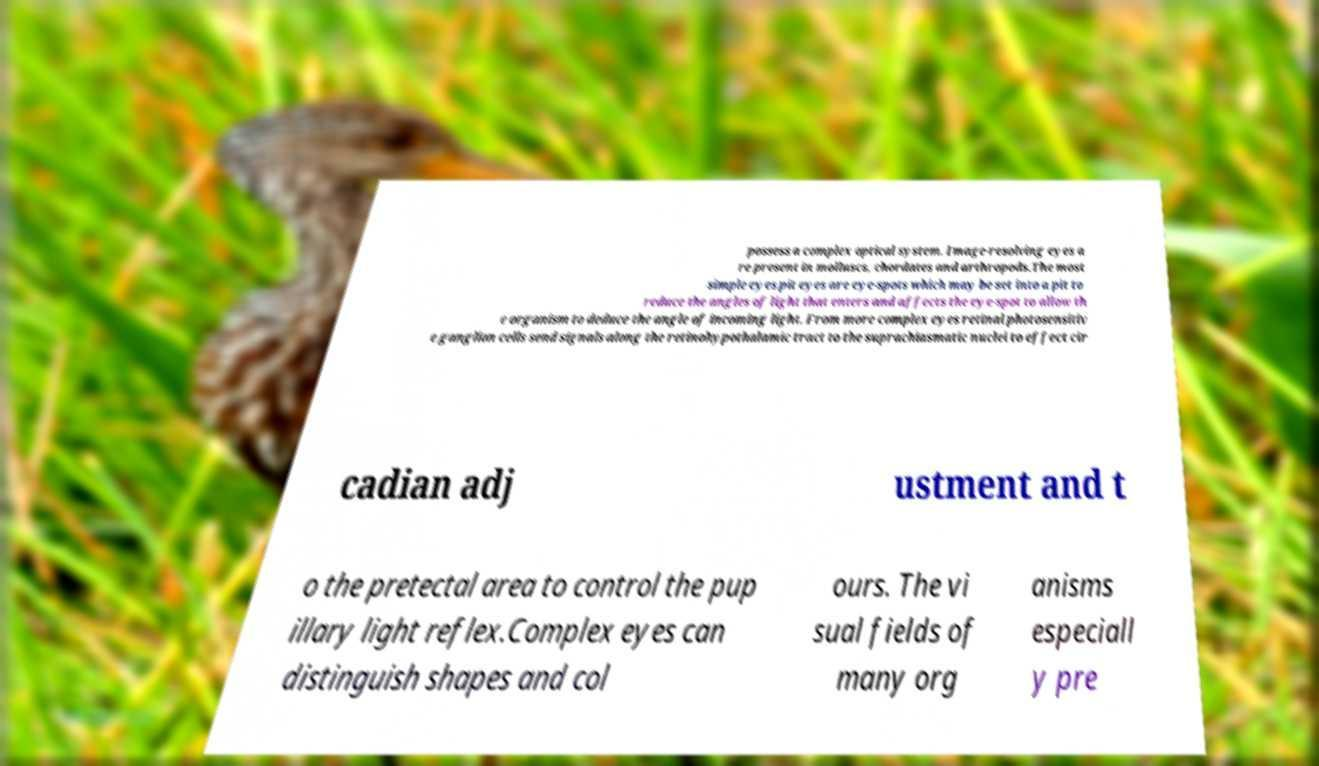What messages or text are displayed in this image? I need them in a readable, typed format. possess a complex optical system. Image-resolving eyes a re present in molluscs, chordates and arthropods.The most simple eyes pit eyes are eye-spots which may be set into a pit to reduce the angles of light that enters and affects the eye-spot to allow th e organism to deduce the angle of incoming light. From more complex eyes retinal photosensitiv e ganglion cells send signals along the retinohypothalamic tract to the suprachiasmatic nuclei to effect cir cadian adj ustment and t o the pretectal area to control the pup illary light reflex.Complex eyes can distinguish shapes and col ours. The vi sual fields of many org anisms especiall y pre 